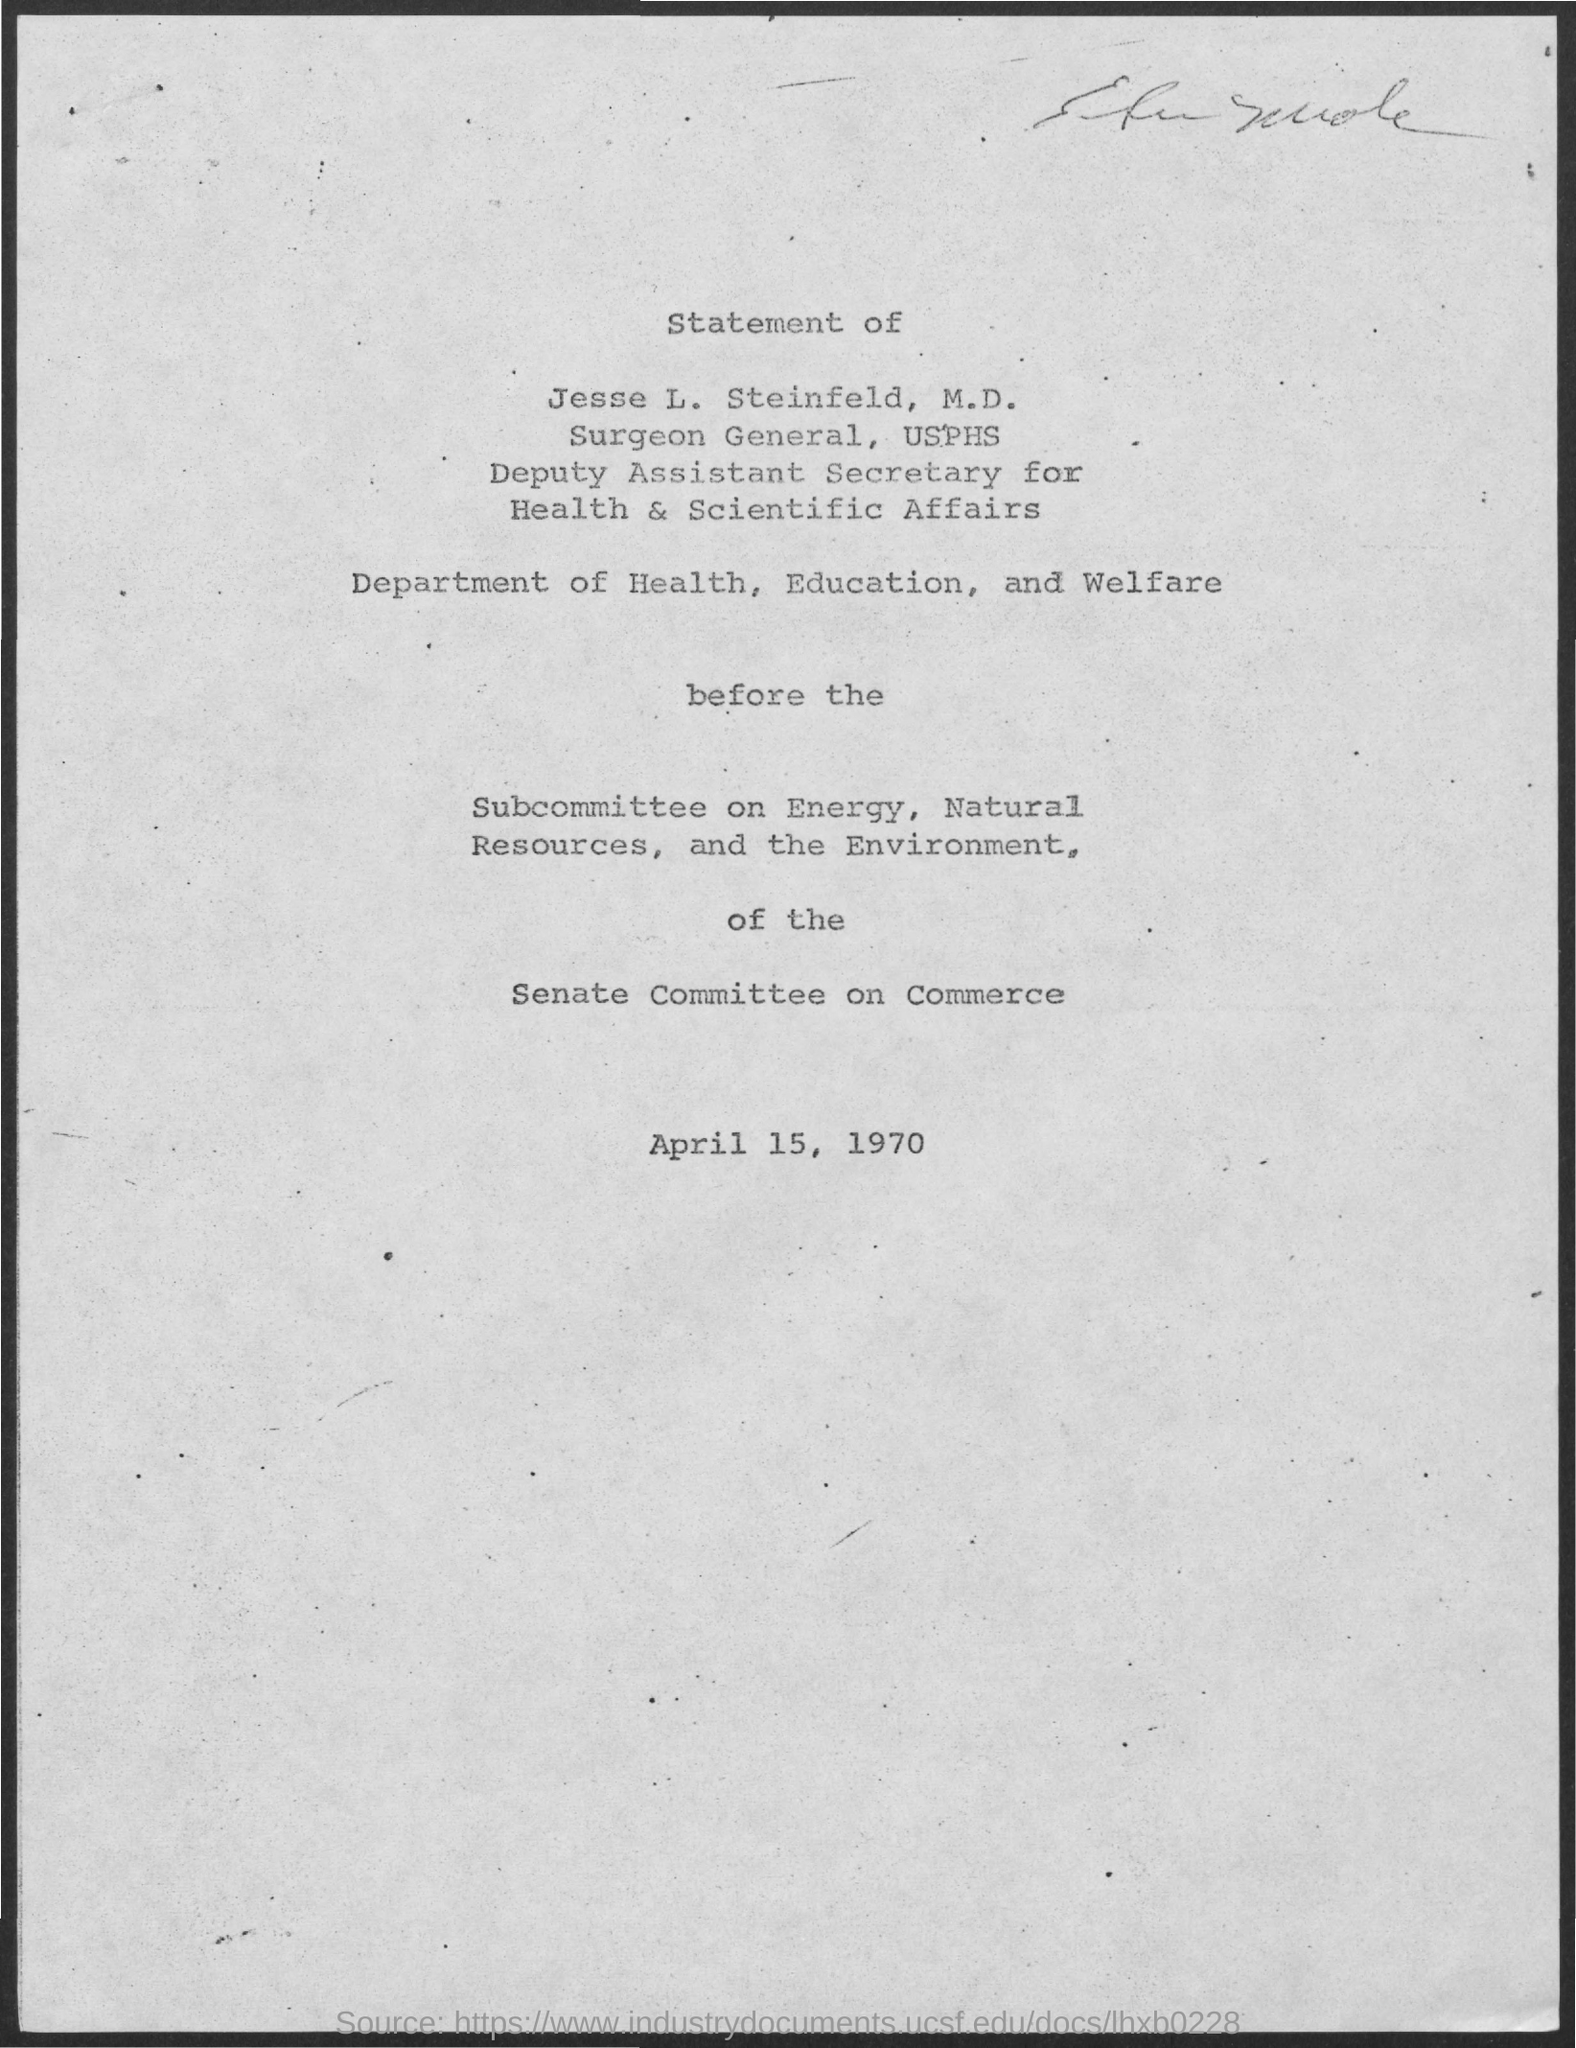What is the date mentioned in the given page ?
Offer a terse response. April 15, 1970. What is the name of the department mentioned ?
Your answer should be compact. Department of health, education and welfare. 